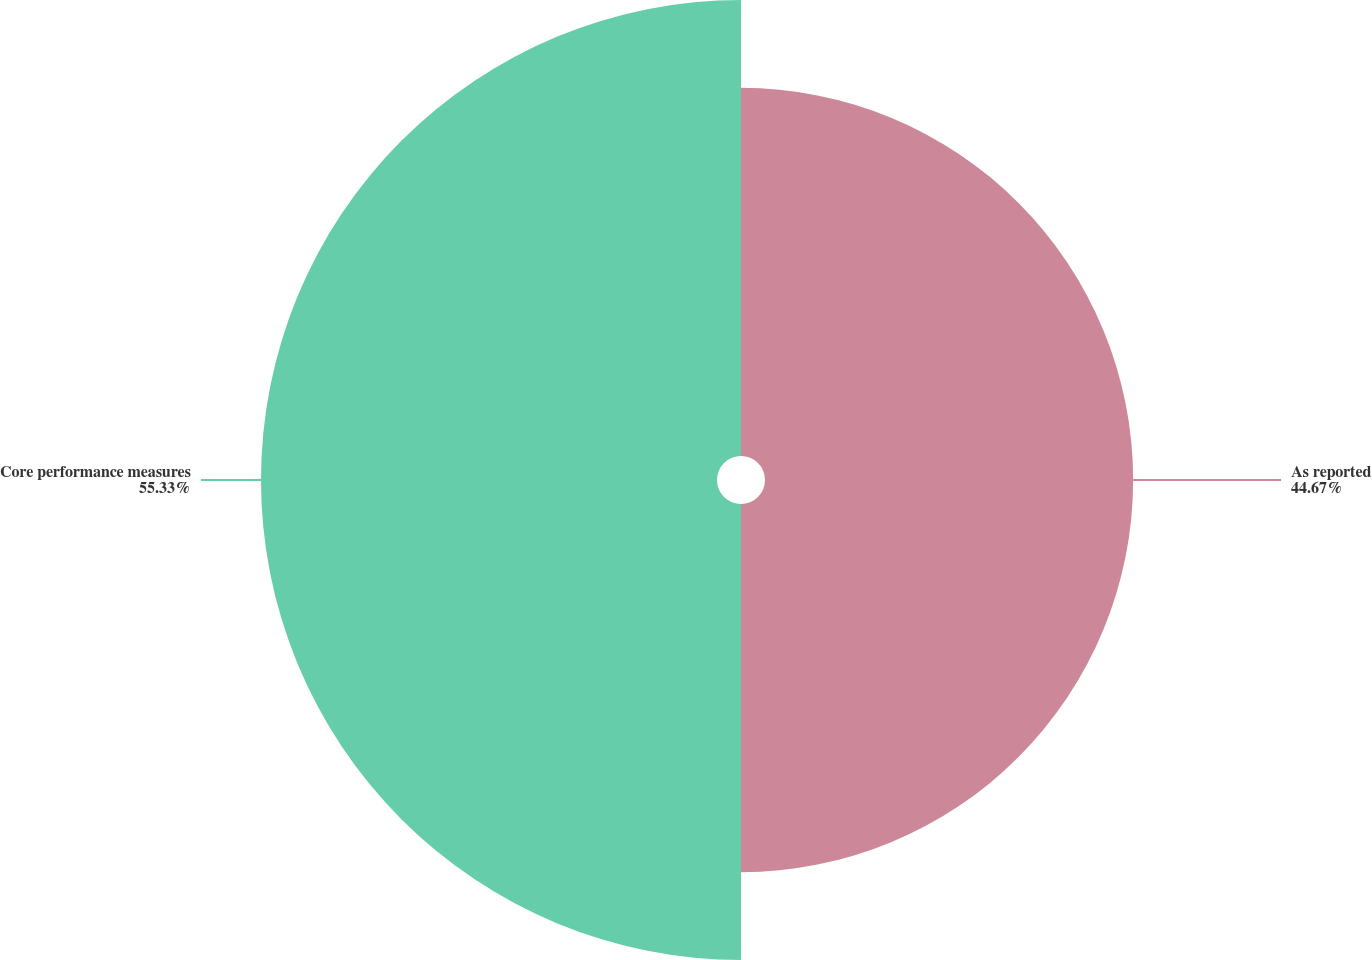Convert chart. <chart><loc_0><loc_0><loc_500><loc_500><pie_chart><fcel>As reported<fcel>Core performance measures<nl><fcel>44.67%<fcel>55.33%<nl></chart> 